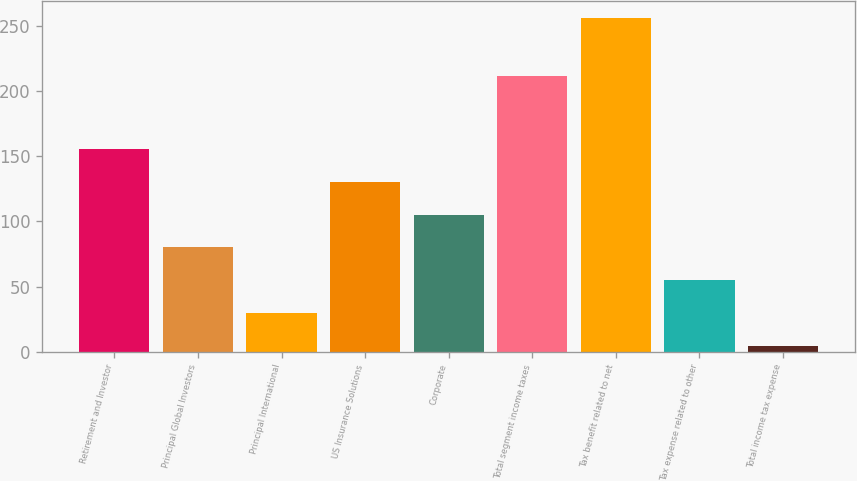Convert chart to OTSL. <chart><loc_0><loc_0><loc_500><loc_500><bar_chart><fcel>Retirement and Investor<fcel>Principal Global Investors<fcel>Principal International<fcel>US Insurance Solutions<fcel>Corporate<fcel>Total segment income taxes<fcel>Tax benefit related to net<fcel>Tax expense related to other<fcel>Total income tax expense<nl><fcel>155.64<fcel>80.07<fcel>29.69<fcel>130.45<fcel>105.26<fcel>211.9<fcel>256.4<fcel>54.88<fcel>4.5<nl></chart> 